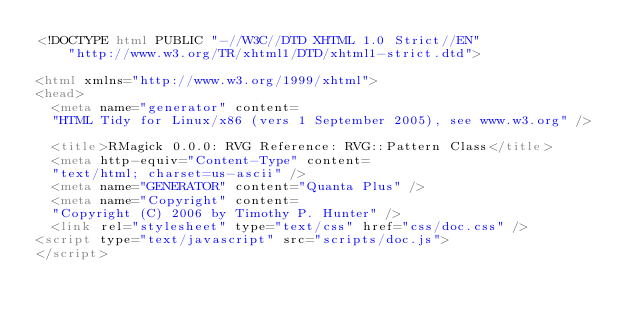<code> <loc_0><loc_0><loc_500><loc_500><_HTML_><!DOCTYPE html PUBLIC "-//W3C//DTD XHTML 1.0 Strict//EN"
    "http://www.w3.org/TR/xhtml1/DTD/xhtml1-strict.dtd">

<html xmlns="http://www.w3.org/1999/xhtml">
<head>
  <meta name="generator" content=
  "HTML Tidy for Linux/x86 (vers 1 September 2005), see www.w3.org" />

  <title>RMagick 0.0.0: RVG Reference: RVG::Pattern Class</title>
  <meta http-equiv="Content-Type" content=
  "text/html; charset=us-ascii" />
  <meta name="GENERATOR" content="Quanta Plus" />
  <meta name="Copyright" content=
  "Copyright (C) 2006 by Timothy P. Hunter" />
  <link rel="stylesheet" type="text/css" href="css/doc.css" />
<script type="text/javascript" src="scripts/doc.js">
</script></code> 